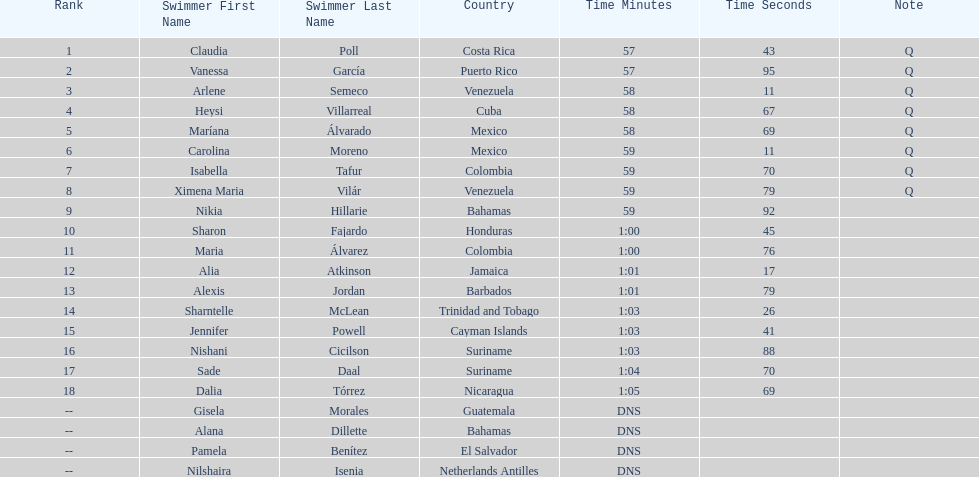I'm looking to parse the entire table for insights. Could you assist me with that? {'header': ['Rank', 'Swimmer First Name', 'Swimmer Last Name', 'Country', 'Time Minutes', 'Time Seconds', 'Note'], 'rows': [['1', 'Claudia', 'Poll', 'Costa Rica', '57', '43', 'Q'], ['2', 'Vanessa', 'García', 'Puerto Rico', '57', '95', 'Q'], ['3', 'Arlene', 'Semeco', 'Venezuela', '58', '11', 'Q'], ['4', 'Heysi', 'Villarreal', 'Cuba', '58', '67', 'Q'], ['5', 'Maríana', 'Álvarado', 'Mexico', '58', '69', 'Q'], ['6', 'Carolina', 'Moreno', 'Mexico', '59', '11', 'Q'], ['7', 'Isabella', 'Tafur', 'Colombia', '59', '70', 'Q'], ['8', 'Ximena Maria', 'Vilár', 'Venezuela', '59', '79', 'Q'], ['9', 'Nikia', 'Hillarie', 'Bahamas', '59', '92', ''], ['10', 'Sharon', 'Fajardo', 'Honduras', '1:00', '45', ''], ['11', 'Maria', 'Álvarez', 'Colombia', '1:00', '76', ''], ['12', 'Alia', 'Atkinson', 'Jamaica', '1:01', '17', ''], ['13', 'Alexis', 'Jordan', 'Barbados', '1:01', '79', ''], ['14', 'Sharntelle', 'McLean', 'Trinidad and Tobago', '1:03', '26', ''], ['15', 'Jennifer', 'Powell', 'Cayman Islands', '1:03', '41', ''], ['16', 'Nishani', 'Cicilson', 'Suriname', '1:03', '88', ''], ['17', 'Sade', 'Daal', 'Suriname', '1:04', '70', ''], ['18', 'Dalia', 'Tórrez', 'Nicaragua', '1:05', '69', ''], ['--', 'Gisela', 'Morales', 'Guatemala', 'DNS', '', ''], ['--', 'Alana', 'Dillette', 'Bahamas', 'DNS', '', ''], ['--', 'Pamela', 'Benítez', 'El Salvador', 'DNS', '', ''], ['--', 'Nilshaira', 'Isenia', 'Netherlands Antilles', 'DNS', '', '']]} How many competitors from venezuela qualified for the final? 2. 